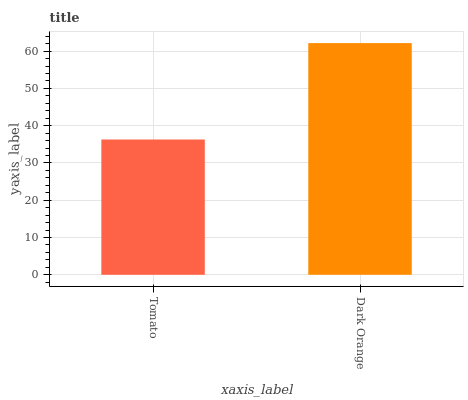Is Tomato the minimum?
Answer yes or no. Yes. Is Dark Orange the maximum?
Answer yes or no. Yes. Is Dark Orange the minimum?
Answer yes or no. No. Is Dark Orange greater than Tomato?
Answer yes or no. Yes. Is Tomato less than Dark Orange?
Answer yes or no. Yes. Is Tomato greater than Dark Orange?
Answer yes or no. No. Is Dark Orange less than Tomato?
Answer yes or no. No. Is Dark Orange the high median?
Answer yes or no. Yes. Is Tomato the low median?
Answer yes or no. Yes. Is Tomato the high median?
Answer yes or no. No. Is Dark Orange the low median?
Answer yes or no. No. 